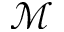<formula> <loc_0><loc_0><loc_500><loc_500>\mathcal { M }</formula> 